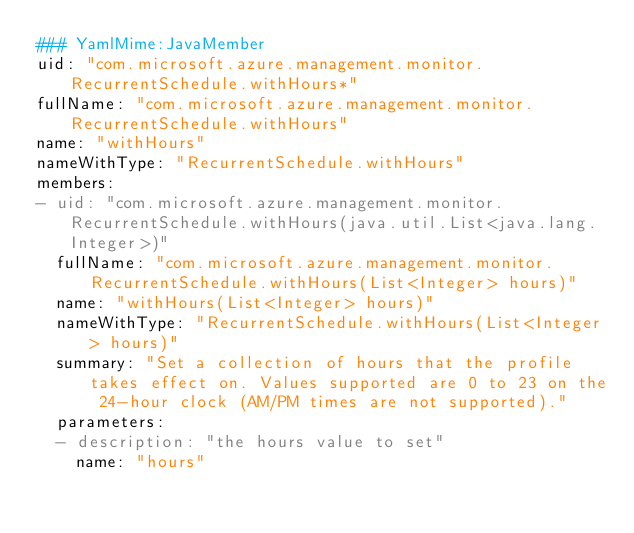<code> <loc_0><loc_0><loc_500><loc_500><_YAML_>### YamlMime:JavaMember
uid: "com.microsoft.azure.management.monitor.RecurrentSchedule.withHours*"
fullName: "com.microsoft.azure.management.monitor.RecurrentSchedule.withHours"
name: "withHours"
nameWithType: "RecurrentSchedule.withHours"
members:
- uid: "com.microsoft.azure.management.monitor.RecurrentSchedule.withHours(java.util.List<java.lang.Integer>)"
  fullName: "com.microsoft.azure.management.monitor.RecurrentSchedule.withHours(List<Integer> hours)"
  name: "withHours(List<Integer> hours)"
  nameWithType: "RecurrentSchedule.withHours(List<Integer> hours)"
  summary: "Set a collection of hours that the profile takes effect on. Values supported are 0 to 23 on the 24-hour clock (AM/PM times are not supported)."
  parameters:
  - description: "the hours value to set"
    name: "hours"</code> 